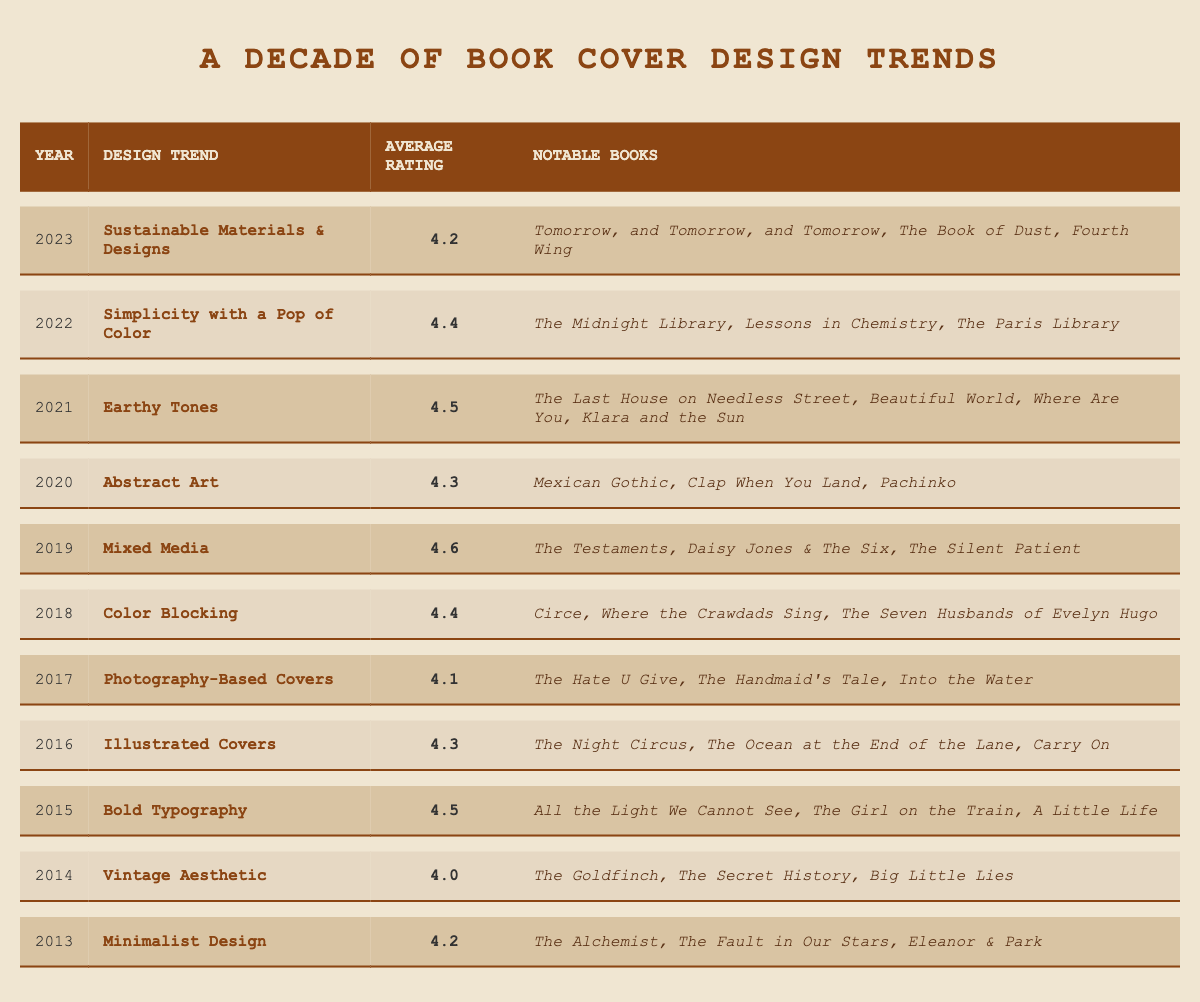What was the design trend for 2019? The table shows that in 2019, the design trend was "Mixed Media."
Answer: Mixed Media Which year had the highest average rating? By examining the average ratings, 2019 has the highest rating at 4.6.
Answer: 2019 What is the average rating from 2016 to 2020? The average for these years is calculated as follows: (4.3 + 4.1 + 4.3 + 4.5) = 17.2, and then divided by 5, resulting in 17.2/5 = 4.34.
Answer: 4.34 Was the average rating in 2022 higher than in 2021? The average rating for 2022 is 4.4 while for 2021 it is 4.5; this means the 2022 rating was lower.
Answer: No Which design trend appeared earliest, and what was its average rating? The table shows that the earliest design trend in 2013 was "Minimalist Design," with an average rating of 4.2.
Answer: Minimalist Design, 4.2 How does the average rating for "Bold Typography" compare to the average rating for "Earthy Tones"? The rating for "Bold Typography" is 4.5 while "Earthy Tones" is also 4.5; they are equal.
Answer: They are equal What percentage of the years listed had an average rating of 4.4 or higher? Out of 11 years, five years (2015, 2018, 2019, 2021, 2022) had ratings of 4.4 or higher, which is (5/11) * 100 = 45.45%.
Answer: Approximately 45.45% Which design trend had the lowest average rating, and what was it? The design trend with the lowest average rating is "Vintage Aesthetic" from 2014, which had an average rating of 4.0.
Answer: Vintage Aesthetic, 4.0 If we consider the books from 2016 and 2019 together, how many notable books were there? In 2016, there were 3 notable books, and in 2019, there were 3 notable books, totaling 6 notable books.
Answer: 6 Which year saw a shift from more illustrative covers to simpler designs? The trend shifted from "Illustrated Covers" in 2016 (more complex) to "Simplicity with a Pop of Color" in 2022 (simpler).
Answer: 2016 to 2022 